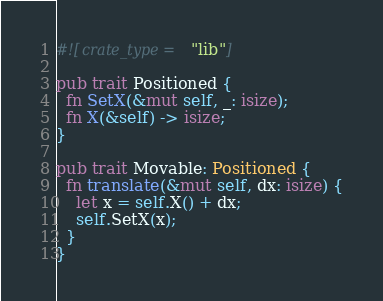Convert code to text. <code><loc_0><loc_0><loc_500><loc_500><_Rust_>
#![crate_type = "lib"]

pub trait Positioned {
  fn SetX(&mut self, _: isize);
  fn X(&self) -> isize;
}

pub trait Movable: Positioned {
  fn translate(&mut self, dx: isize) {
    let x = self.X() + dx;
    self.SetX(x);
  }
}
</code> 